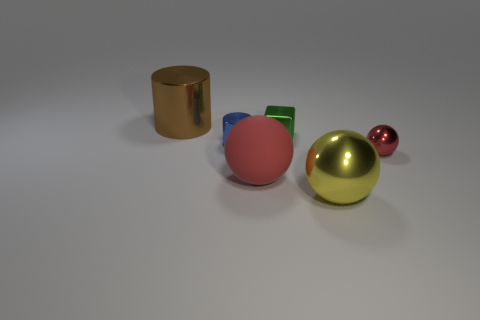Add 1 large shiny cylinders. How many objects exist? 7 Subtract all cubes. How many objects are left? 5 Add 3 big cylinders. How many big cylinders are left? 4 Add 1 tiny red shiny cubes. How many tiny red shiny cubes exist? 1 Subtract 0 red cylinders. How many objects are left? 6 Subtract all big brown matte cylinders. Subtract all large brown cylinders. How many objects are left? 5 